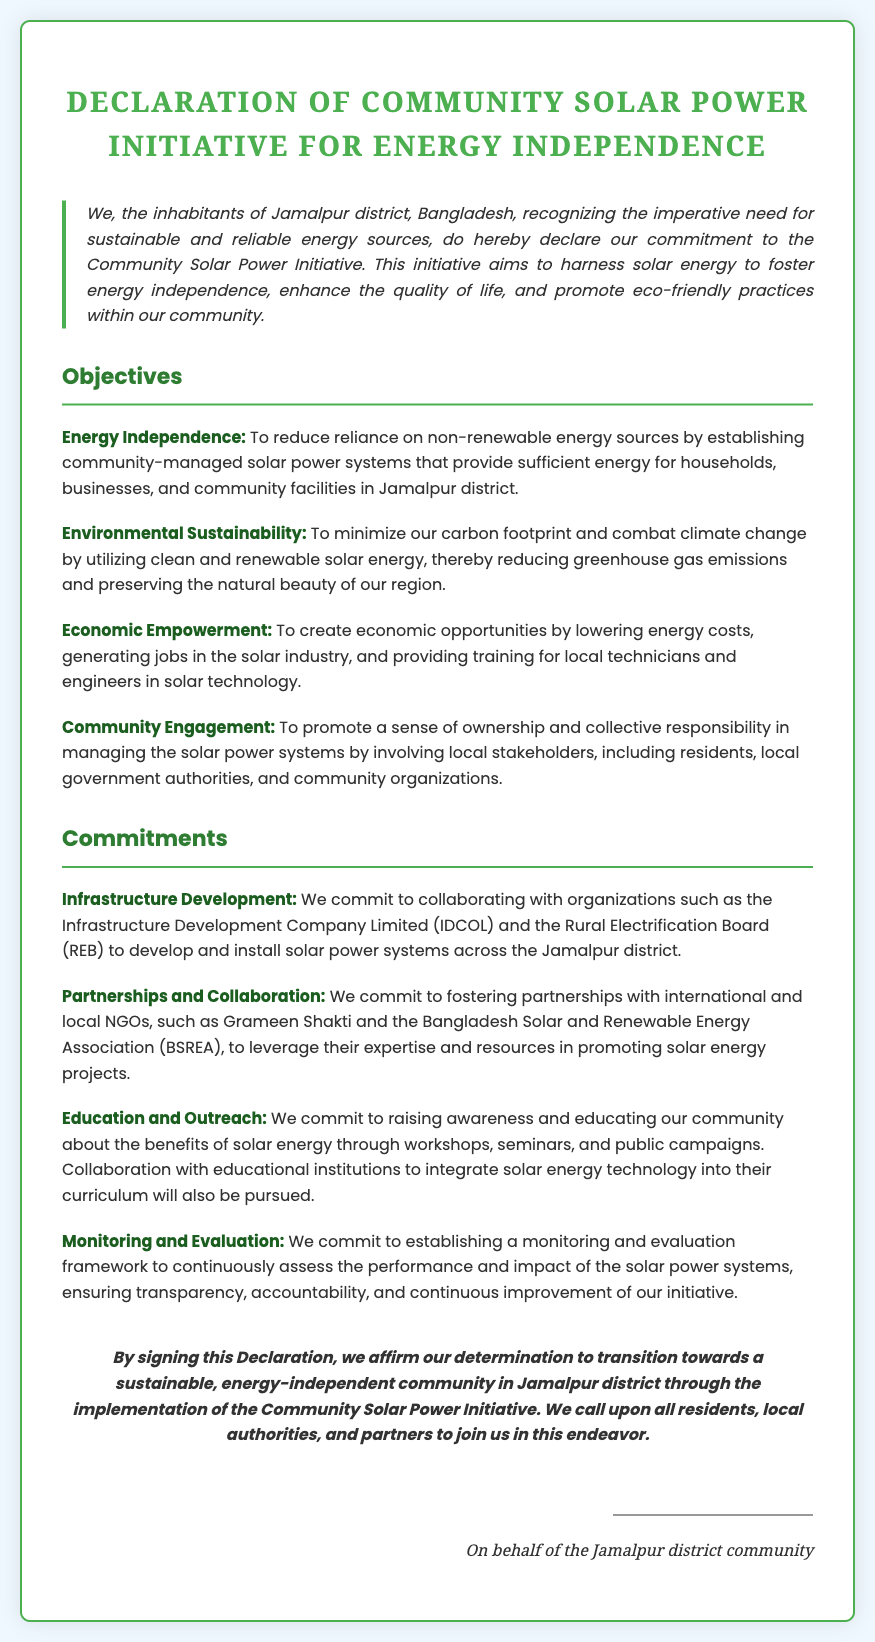what is the title of the document? The title of the document is prominently displayed at the top, indicating the main subject of the declaration.
Answer: Declaration of Community Solar Power Initiative for Energy Independence who are the inhabitants of the declaration? The declaration specifies the group of people committing to the initiative, focusing on their geographical location.
Answer: inhabitants of Jamalpur district, Bangladesh how many objectives are listed in the document? The number of objectives can be counted from the objectives section, providing insight into the initiative's goals.
Answer: four what is one of the commitments related to partnerships? The commitments section outlines specific actions, one of which involves collaboration with various organizations.
Answer: fostering partnerships with international and local NGOs which organization is mentioned in the context of infrastructure development? The commitment to infrastructure development refers to collaborating with a specific organization that has a role in such projects.
Answer: Infrastructure Development Company Limited (IDCOL) what is the primary aim of the Community Solar Power Initiative? The document expresses a key goal regarding the benefits of harnessing solar energy for the community.
Answer: energy independence what type of monitoring framework will be established? The initiative mentions a specific process for overseeing the effectiveness and impact of the solar projects.
Answer: monitoring and evaluation framework what does the conclusion call upon? The conclusion emphasizes action from specific groups to join in the initiative, indicating a call to collective action.
Answer: all residents, local authorities, and partners 